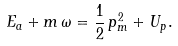Convert formula to latex. <formula><loc_0><loc_0><loc_500><loc_500>E _ { a } + m \, \omega = \frac { 1 } { 2 } \, { p } _ { m } ^ { 2 } + U _ { p } .</formula> 